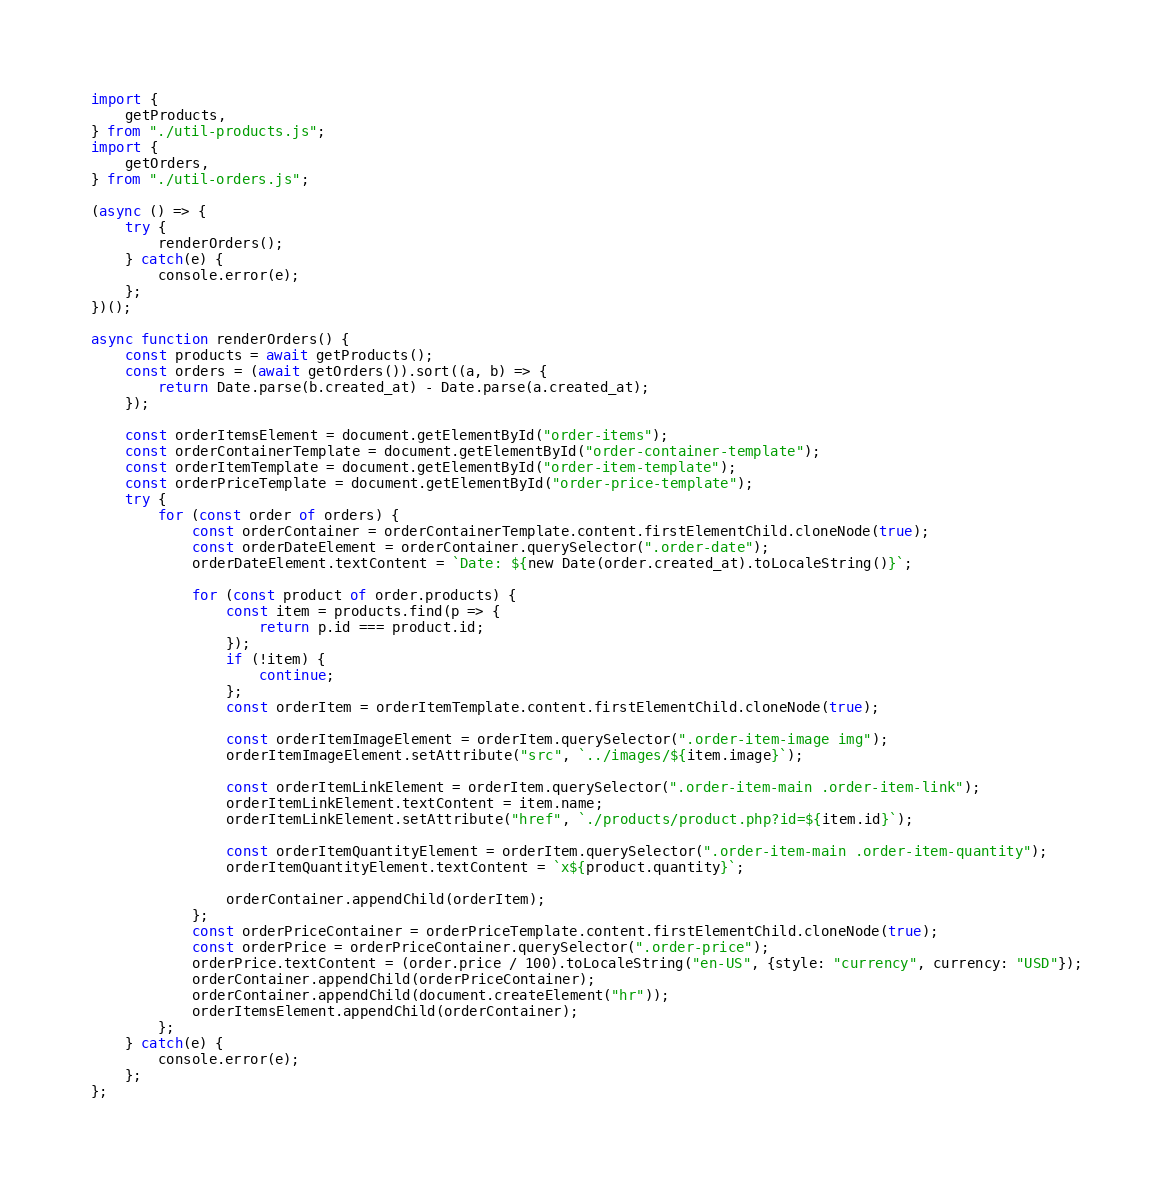Convert code to text. <code><loc_0><loc_0><loc_500><loc_500><_JavaScript_>import {
    getProducts,
} from "./util-products.js";
import {
    getOrders,
} from "./util-orders.js";

(async () => {
    try {
        renderOrders();
    } catch(e) {
        console.error(e);
    };
})();

async function renderOrders() {
    const products = await getProducts();
    const orders = (await getOrders()).sort((a, b) => {
        return Date.parse(b.created_at) - Date.parse(a.created_at);
    });

    const orderItemsElement = document.getElementById("order-items");
    const orderContainerTemplate = document.getElementById("order-container-template");
    const orderItemTemplate = document.getElementById("order-item-template");
    const orderPriceTemplate = document.getElementById("order-price-template");
    try {
        for (const order of orders) {
            const orderContainer = orderContainerTemplate.content.firstElementChild.cloneNode(true);
            const orderDateElement = orderContainer.querySelector(".order-date");
            orderDateElement.textContent = `Date: ${new Date(order.created_at).toLocaleString()}`;

            for (const product of order.products) {
                const item = products.find(p => {
                    return p.id === product.id;
                });
                if (!item) {
                    continue;
                };
                const orderItem = orderItemTemplate.content.firstElementChild.cloneNode(true);

                const orderItemImageElement = orderItem.querySelector(".order-item-image img");
                orderItemImageElement.setAttribute("src", `../images/${item.image}`);

                const orderItemLinkElement = orderItem.querySelector(".order-item-main .order-item-link");
                orderItemLinkElement.textContent = item.name;
                orderItemLinkElement.setAttribute("href", `./products/product.php?id=${item.id}`);

                const orderItemQuantityElement = orderItem.querySelector(".order-item-main .order-item-quantity");
                orderItemQuantityElement.textContent = `x${product.quantity}`;

                orderContainer.appendChild(orderItem);
            };
            const orderPriceContainer = orderPriceTemplate.content.firstElementChild.cloneNode(true);
            const orderPrice = orderPriceContainer.querySelector(".order-price");
            orderPrice.textContent = (order.price / 100).toLocaleString("en-US", {style: "currency", currency: "USD"});
            orderContainer.appendChild(orderPriceContainer);
            orderContainer.appendChild(document.createElement("hr"));
            orderItemsElement.appendChild(orderContainer);
        };
    } catch(e) {
        console.error(e);
    };
};</code> 